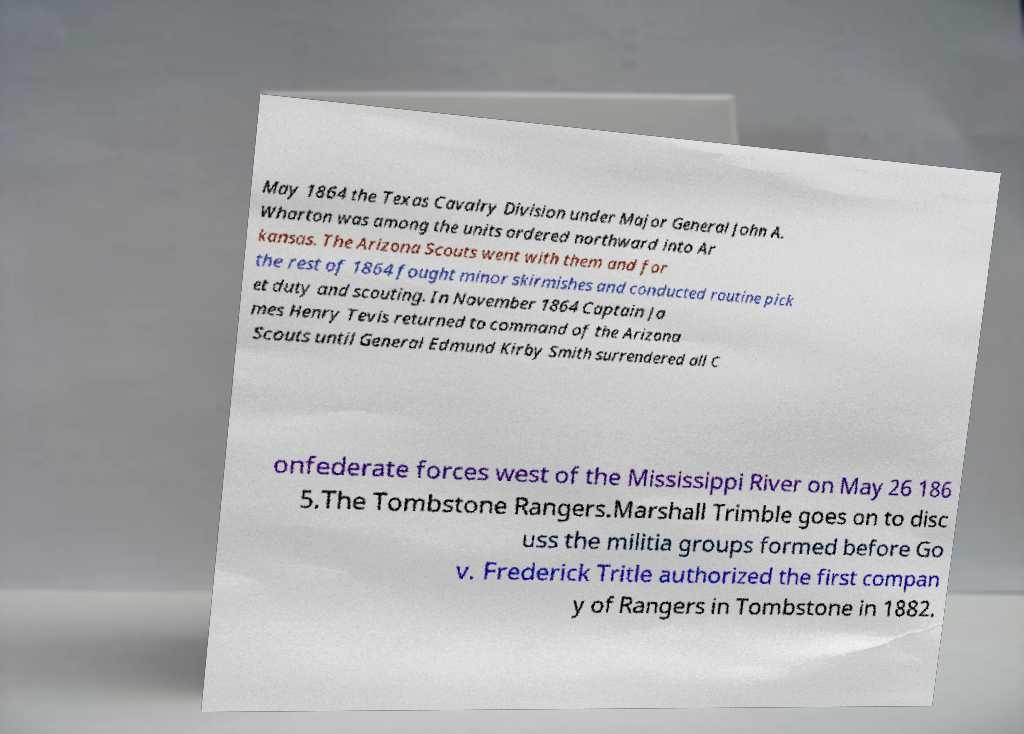There's text embedded in this image that I need extracted. Can you transcribe it verbatim? May 1864 the Texas Cavalry Division under Major General John A. Wharton was among the units ordered northward into Ar kansas. The Arizona Scouts went with them and for the rest of 1864 fought minor skirmishes and conducted routine pick et duty and scouting. In November 1864 Captain Ja mes Henry Tevis returned to command of the Arizona Scouts until General Edmund Kirby Smith surrendered all C onfederate forces west of the Mississippi River on May 26 186 5.The Tombstone Rangers.Marshall Trimble goes on to disc uss the militia groups formed before Go v. Frederick Tritle authorized the first compan y of Rangers in Tombstone in 1882. 